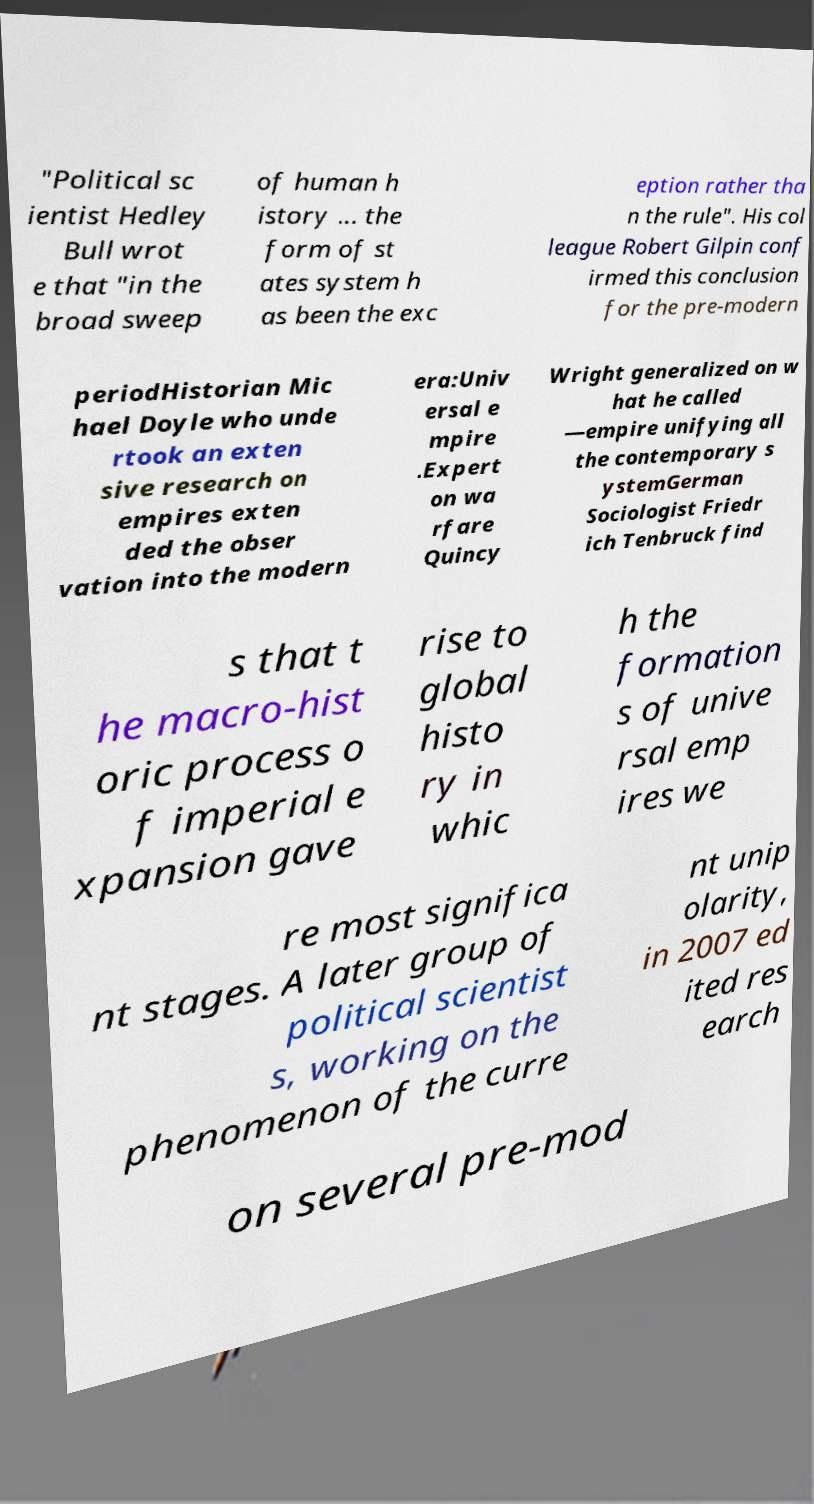Please read and relay the text visible in this image. What does it say? "Political sc ientist Hedley Bull wrot e that "in the broad sweep of human h istory ... the form of st ates system h as been the exc eption rather tha n the rule". His col league Robert Gilpin conf irmed this conclusion for the pre-modern periodHistorian Mic hael Doyle who unde rtook an exten sive research on empires exten ded the obser vation into the modern era:Univ ersal e mpire .Expert on wa rfare Quincy Wright generalized on w hat he called —empire unifying all the contemporary s ystemGerman Sociologist Friedr ich Tenbruck find s that t he macro-hist oric process o f imperial e xpansion gave rise to global histo ry in whic h the formation s of unive rsal emp ires we re most significa nt stages. A later group of political scientist s, working on the phenomenon of the curre nt unip olarity, in 2007 ed ited res earch on several pre-mod 